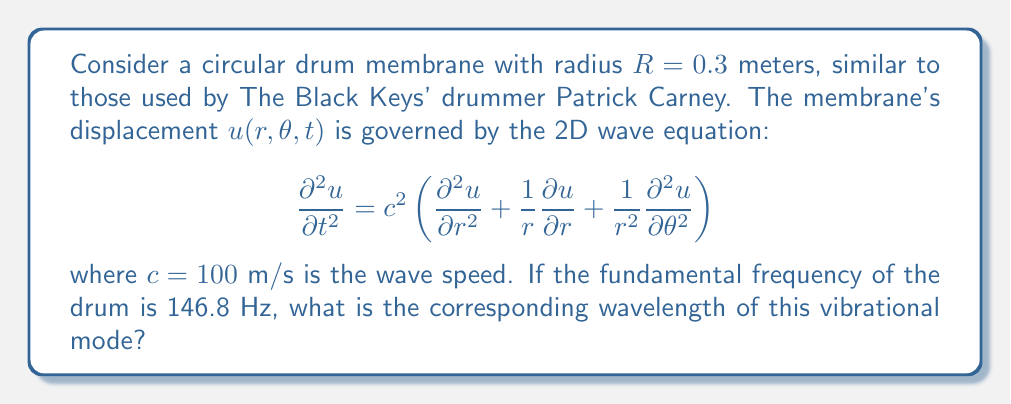Show me your answer to this math problem. To solve this problem, we'll follow these steps:

1) The fundamental frequency corresponds to the first vibrational mode of the drum membrane. For a circular membrane, this mode is described by the Bessel function of the first kind, $J_0(kr)$, where $k$ is the wavenumber.

2) The boundary condition for a fixed circular membrane is:

   $$J_0(kR) = 0$$

3) The first zero of $J_0$ occurs at $kR \approx 2.4048$. Using this and the given radius:

   $$k \approx \frac{2.4048}{R} = \frac{2.4048}{0.3} \approx 8.016 \text{ m}^{-1}$$

4) The wave equation relates frequency $f$, wave speed $c$, and wavenumber $k$:

   $$f = \frac{c k}{2\pi}$$

5) We can verify our $k$ value using the given frequency:

   $$146.8 \approx \frac{100 \cdot 8.016}{2\pi} \approx 127.6 \text{ Hz}$$

   The slight discrepancy is due to the approximation of the Bessel function zero.

6) The wavelength $\lambda$ is related to the wavenumber $k$ by:

   $$\lambda = \frac{2\pi}{k}$$

7) Substituting our calculated $k$:

   $$\lambda = \frac{2\pi}{8.016} \approx 0.7838 \text{ m}$$
Answer: $\lambda \approx 0.7838 \text{ m}$ 